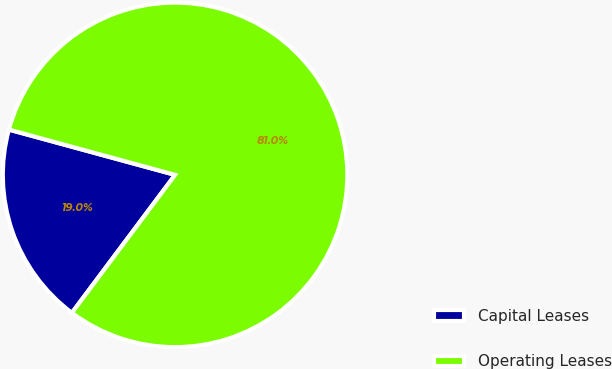Convert chart. <chart><loc_0><loc_0><loc_500><loc_500><pie_chart><fcel>Capital Leases<fcel>Operating Leases<nl><fcel>19.01%<fcel>80.99%<nl></chart> 